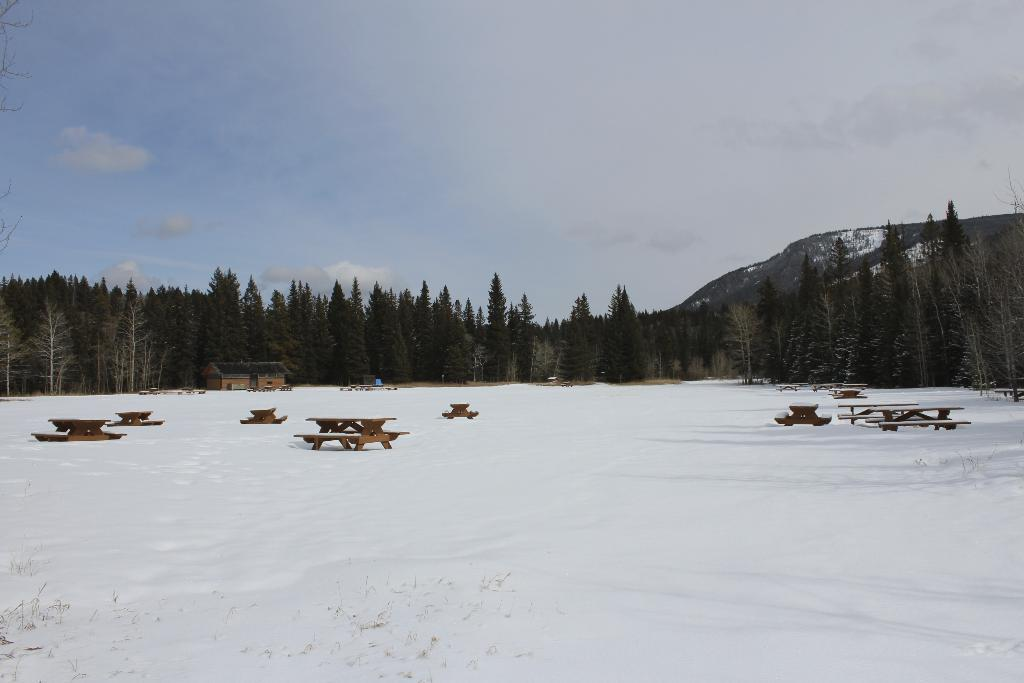What objects are located in the middle of the image? There are benches and trees in the middle of the image. What can be seen at the top of the image? The sky is visible at the top of the image. What is the texture or state of the ice in the image? The ice is present in the image, but its texture or state is not specified. How many chairs are visible in the image? There are no chairs mentioned in the facts provided, so we cannot determine the number of chairs in the image. Is there a pig present in the image? There is no mention of a pig in the facts provided, so we cannot determine if a pig is present in the image. 